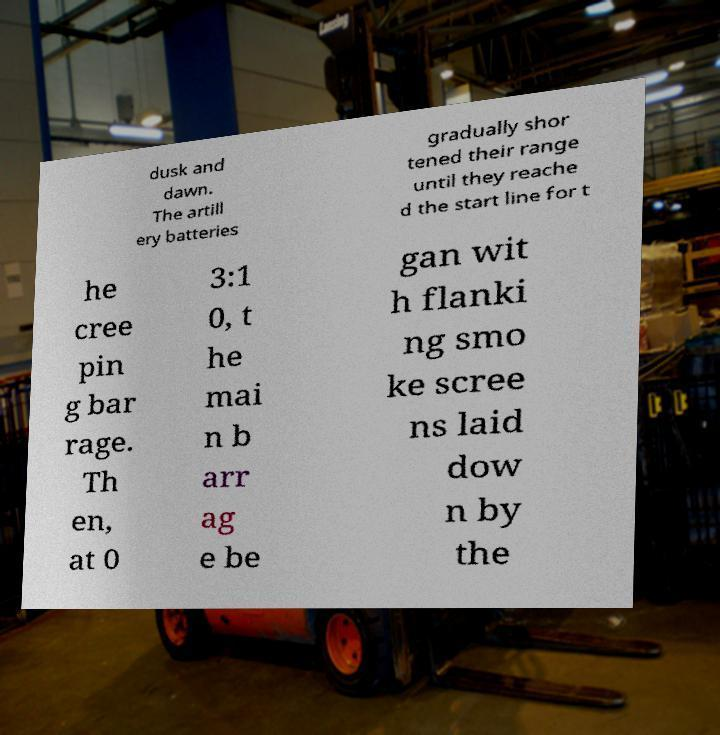Please read and relay the text visible in this image. What does it say? dusk and dawn. The artill ery batteries gradually shor tened their range until they reache d the start line for t he cree pin g bar rage. Th en, at 0 3:1 0, t he mai n b arr ag e be gan wit h flanki ng smo ke scree ns laid dow n by the 